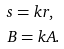<formula> <loc_0><loc_0><loc_500><loc_500>& s = k r , \\ & B = k A .</formula> 